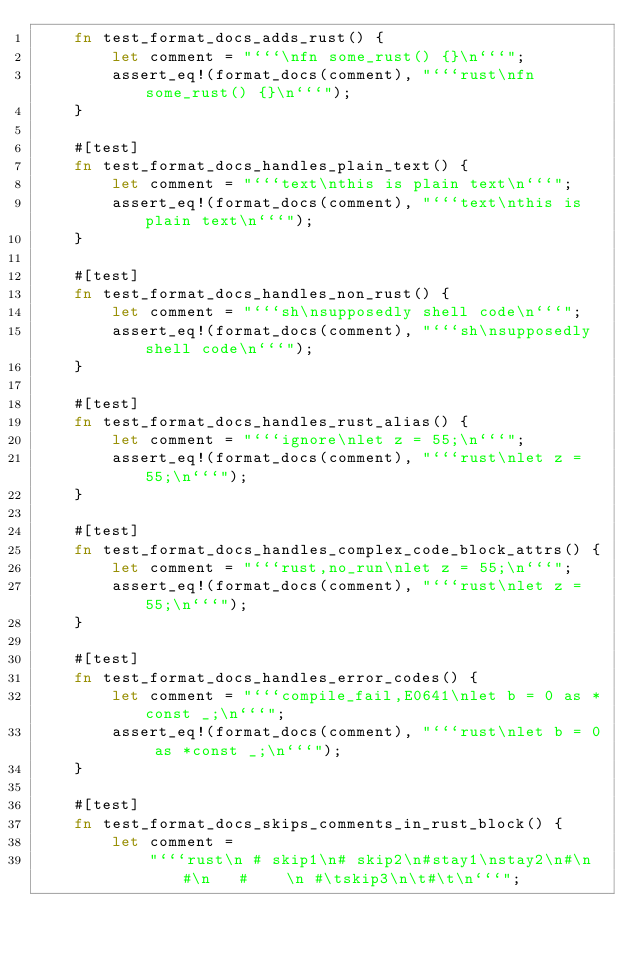<code> <loc_0><loc_0><loc_500><loc_500><_Rust_>    fn test_format_docs_adds_rust() {
        let comment = "```\nfn some_rust() {}\n```";
        assert_eq!(format_docs(comment), "```rust\nfn some_rust() {}\n```");
    }

    #[test]
    fn test_format_docs_handles_plain_text() {
        let comment = "```text\nthis is plain text\n```";
        assert_eq!(format_docs(comment), "```text\nthis is plain text\n```");
    }

    #[test]
    fn test_format_docs_handles_non_rust() {
        let comment = "```sh\nsupposedly shell code\n```";
        assert_eq!(format_docs(comment), "```sh\nsupposedly shell code\n```");
    }

    #[test]
    fn test_format_docs_handles_rust_alias() {
        let comment = "```ignore\nlet z = 55;\n```";
        assert_eq!(format_docs(comment), "```rust\nlet z = 55;\n```");
    }

    #[test]
    fn test_format_docs_handles_complex_code_block_attrs() {
        let comment = "```rust,no_run\nlet z = 55;\n```";
        assert_eq!(format_docs(comment), "```rust\nlet z = 55;\n```");
    }

    #[test]
    fn test_format_docs_handles_error_codes() {
        let comment = "```compile_fail,E0641\nlet b = 0 as *const _;\n```";
        assert_eq!(format_docs(comment), "```rust\nlet b = 0 as *const _;\n```");
    }

    #[test]
    fn test_format_docs_skips_comments_in_rust_block() {
        let comment =
            "```rust\n # skip1\n# skip2\n#stay1\nstay2\n#\n #\n   #    \n #\tskip3\n\t#\t\n```";</code> 